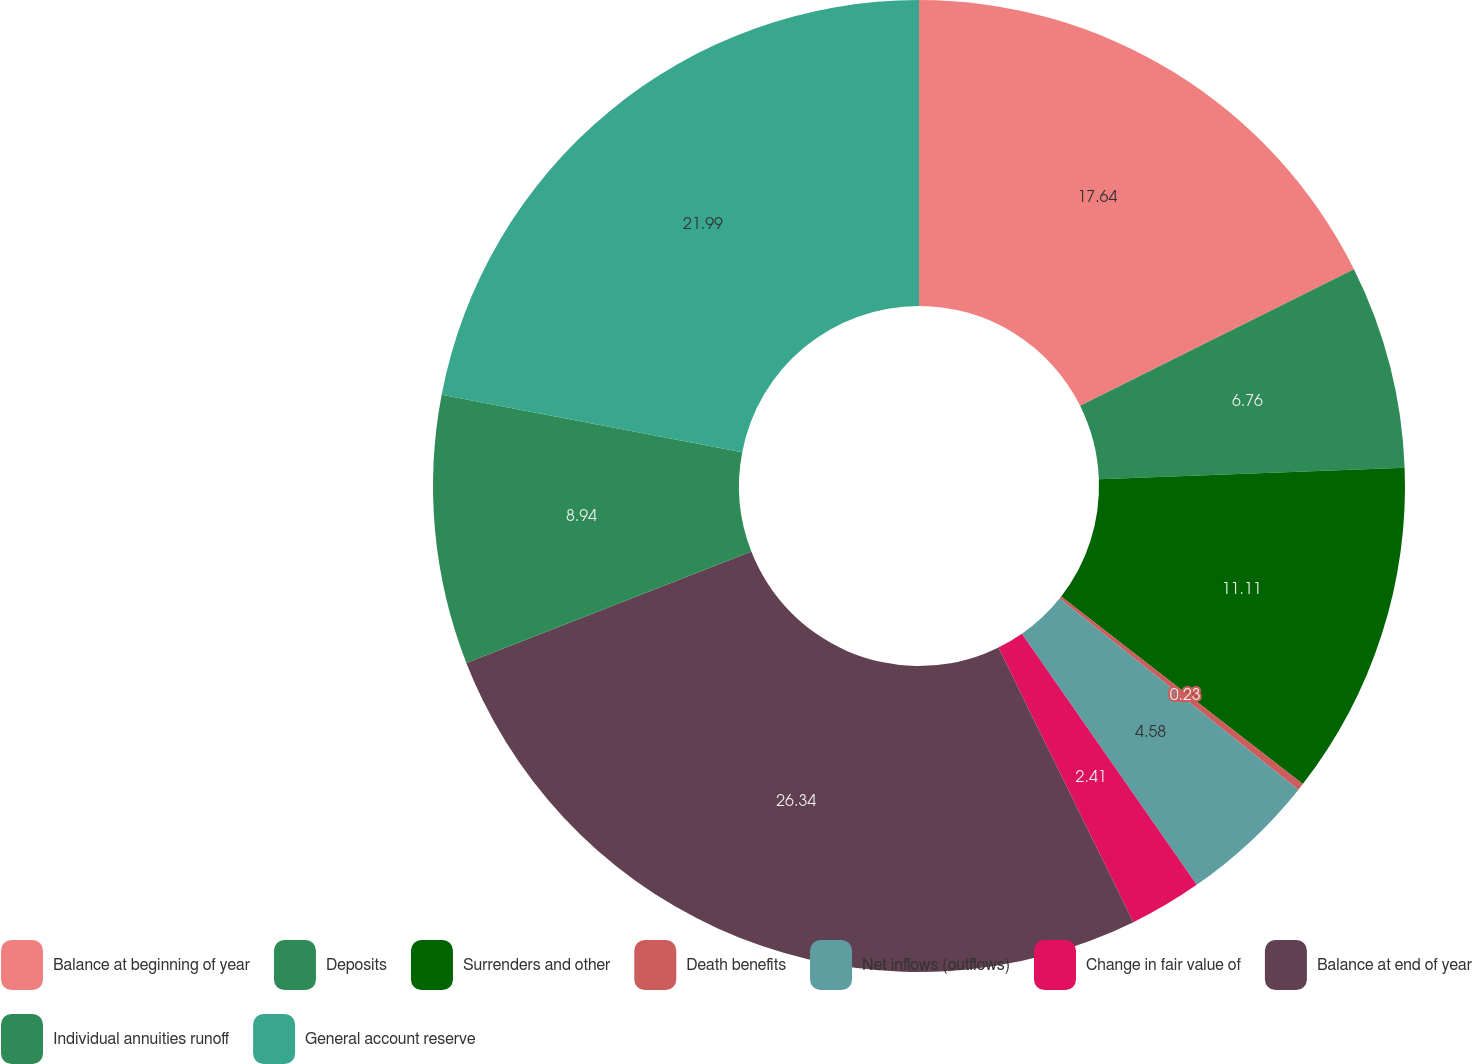<chart> <loc_0><loc_0><loc_500><loc_500><pie_chart><fcel>Balance at beginning of year<fcel>Deposits<fcel>Surrenders and other<fcel>Death benefits<fcel>Net inflows (outflows)<fcel>Change in fair value of<fcel>Balance at end of year<fcel>Individual annuities runoff<fcel>General account reserve<nl><fcel>17.64%<fcel>6.76%<fcel>11.11%<fcel>0.23%<fcel>4.58%<fcel>2.41%<fcel>26.34%<fcel>8.94%<fcel>21.99%<nl></chart> 